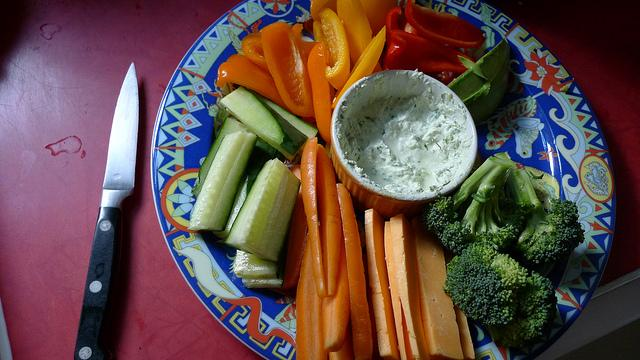What is the white substance in the middle of the plate used for? Please explain your reasoning. dipping. The ranch dip in the middle is for the veggie dippers. 